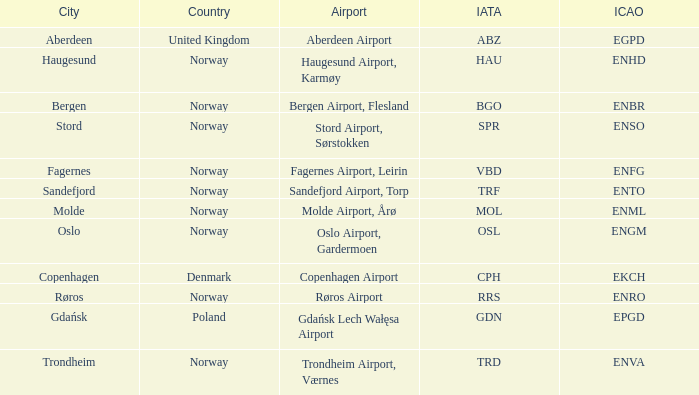What is the Airport in Oslo? Oslo Airport, Gardermoen. Parse the table in full. {'header': ['City', 'Country', 'Airport', 'IATA', 'ICAO'], 'rows': [['Aberdeen', 'United Kingdom', 'Aberdeen Airport', 'ABZ', 'EGPD'], ['Haugesund', 'Norway', 'Haugesund Airport, Karmøy', 'HAU', 'ENHD'], ['Bergen', 'Norway', 'Bergen Airport, Flesland', 'BGO', 'ENBR'], ['Stord', 'Norway', 'Stord Airport, Sørstokken', 'SPR', 'ENSO'], ['Fagernes', 'Norway', 'Fagernes Airport, Leirin', 'VBD', 'ENFG'], ['Sandefjord', 'Norway', 'Sandefjord Airport, Torp', 'TRF', 'ENTO'], ['Molde', 'Norway', 'Molde Airport, Årø', 'MOL', 'ENML'], ['Oslo', 'Norway', 'Oslo Airport, Gardermoen', 'OSL', 'ENGM'], ['Copenhagen', 'Denmark', 'Copenhagen Airport', 'CPH', 'EKCH'], ['Røros', 'Norway', 'Røros Airport', 'RRS', 'ENRO'], ['Gdańsk', 'Poland', 'Gdańsk Lech Wałęsa Airport', 'GDN', 'EPGD'], ['Trondheim', 'Norway', 'Trondheim Airport, Værnes', 'TRD', 'ENVA']]} 